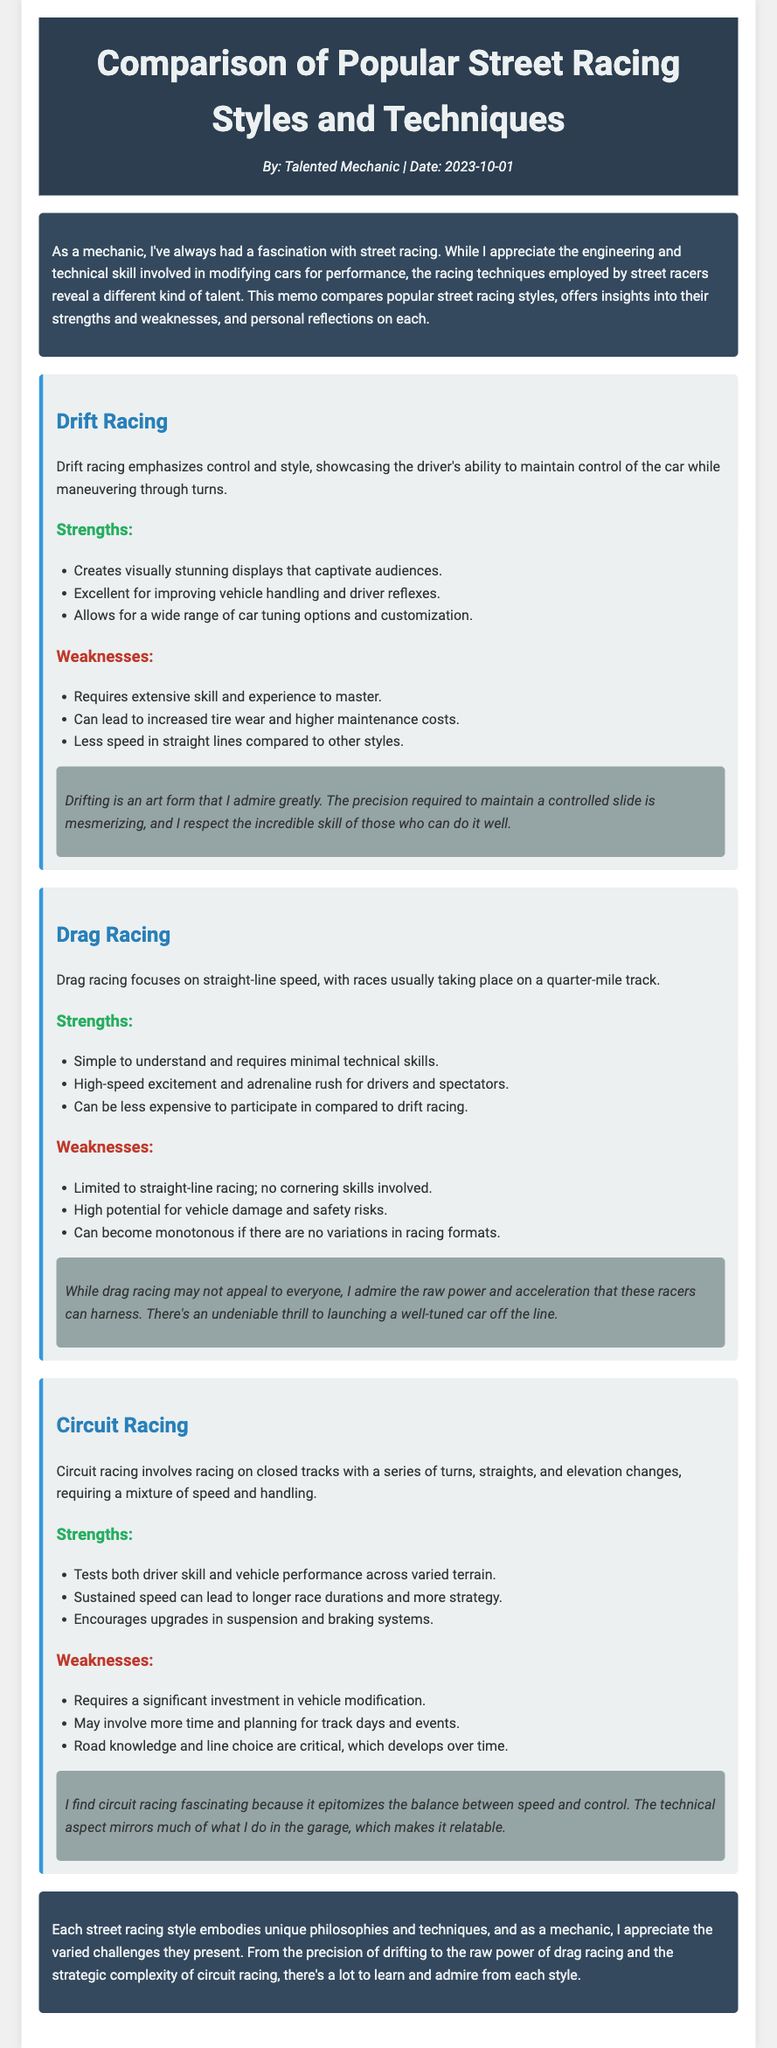What are the three street racing styles mentioned? The document lists three styles: Drift Racing, Drag Racing, and Circuit Racing.
Answer: Drift Racing, Drag Racing, Circuit Racing What are the strengths of Drift Racing? The strengths listed for Drift Racing include visually stunning displays, improved vehicle handling, and tuning options.
Answer: Visually stunning displays, improved vehicle handling, tuning options What is a weakness of Drag Racing? One of the weaknesses of Drag Racing is that it is limited to straight-line racing with no cornering skills involved.
Answer: Limited to straight-line racing What does Circuit Racing require from drivers? Circuit Racing tests both driver skill and vehicle performance across varied terrain.
Answer: Driver skill and vehicle performance What type of racing is simple to understand? Drag Racing is described as simple to understand and requires minimal technical skills.
Answer: Drag Racing What personal insight does the author share about drifting? The author's insight expresses admiration for the precision required to maintain a controlled slide in drifting.
Answer: Admiration for the precision required How does the author feel about circuit racing? The author finds circuit racing fascinating, relating it to the balance between speed and control.
Answer: Fascinating What is commonly required for Circuit Racing? A significant investment in vehicle modification is commonly required for Circuit Racing.
Answer: Significant investment in vehicle modification What is the author's profession? The author identifies as a talented mechanic.
Answer: Talented mechanic 